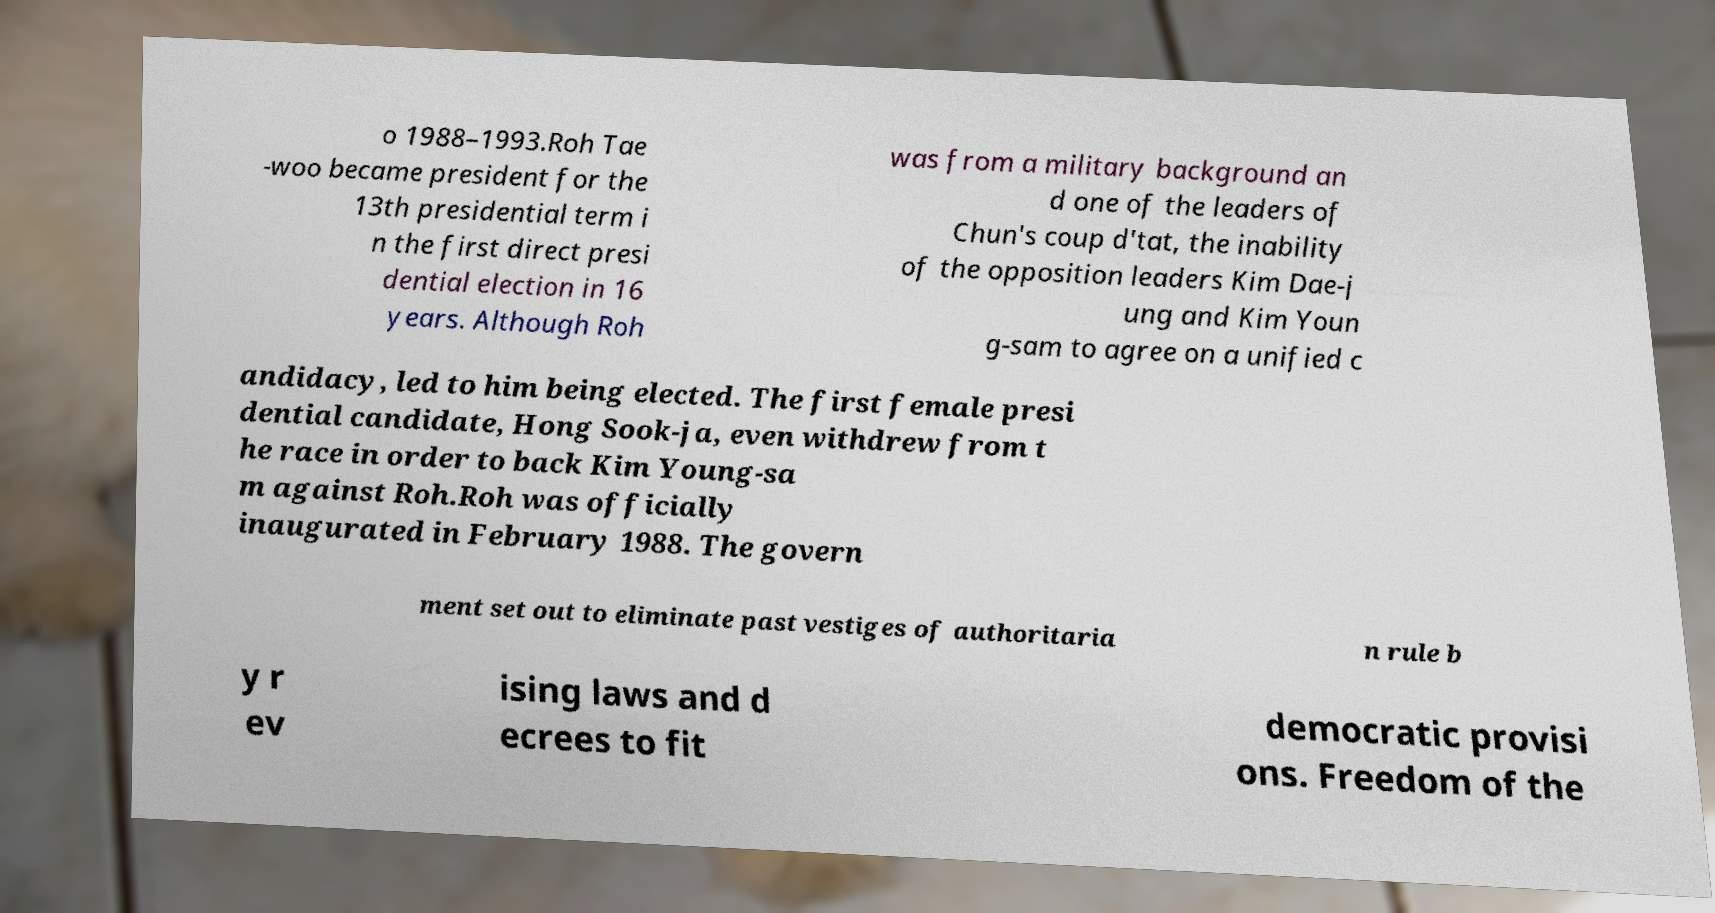Please read and relay the text visible in this image. What does it say? o 1988–1993.Roh Tae -woo became president for the 13th presidential term i n the first direct presi dential election in 16 years. Although Roh was from a military background an d one of the leaders of Chun's coup d'tat, the inability of the opposition leaders Kim Dae-j ung and Kim Youn g-sam to agree on a unified c andidacy, led to him being elected. The first female presi dential candidate, Hong Sook-ja, even withdrew from t he race in order to back Kim Young-sa m against Roh.Roh was officially inaugurated in February 1988. The govern ment set out to eliminate past vestiges of authoritaria n rule b y r ev ising laws and d ecrees to fit democratic provisi ons. Freedom of the 